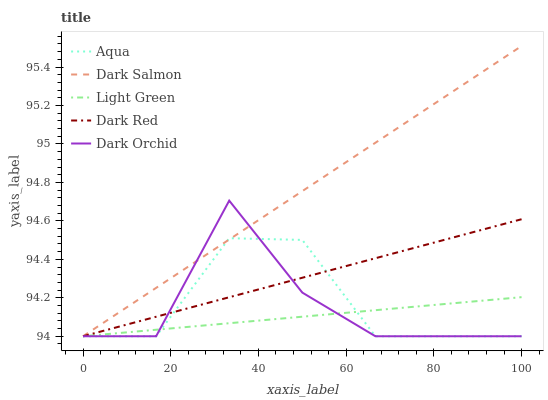Does Light Green have the minimum area under the curve?
Answer yes or no. Yes. Does Dark Salmon have the maximum area under the curve?
Answer yes or no. Yes. Does Dark Red have the minimum area under the curve?
Answer yes or no. No. Does Dark Red have the maximum area under the curve?
Answer yes or no. No. Is Dark Red the smoothest?
Answer yes or no. Yes. Is Dark Orchid the roughest?
Answer yes or no. Yes. Is Aqua the smoothest?
Answer yes or no. No. Is Aqua the roughest?
Answer yes or no. No. Does Dark Orchid have the lowest value?
Answer yes or no. Yes. Does Dark Salmon have the highest value?
Answer yes or no. Yes. Does Dark Red have the highest value?
Answer yes or no. No. Does Aqua intersect Light Green?
Answer yes or no. Yes. Is Aqua less than Light Green?
Answer yes or no. No. Is Aqua greater than Light Green?
Answer yes or no. No. 